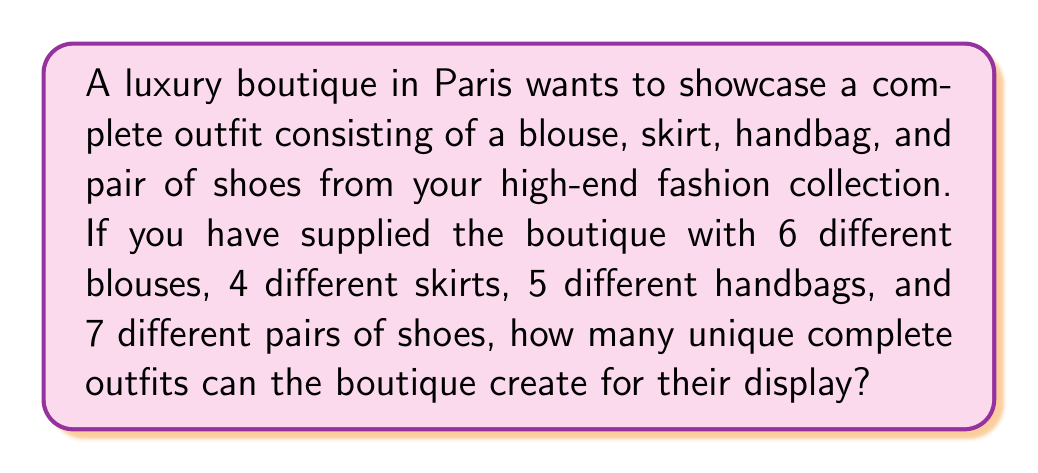Solve this math problem. To solve this problem, we'll use the multiplication principle of counting. Since we need to select one item from each category, and the selection of one item doesn't affect the choices for the other items, we multiply the number of options for each category:

1. Number of blouse options: 6
2. Number of skirt options: 4
3. Number of handbag options: 5
4. Number of shoe options: 7

The total number of unique outfits is the product of these numbers:

$$ \text{Total outfits} = 6 \times 4 \times 5 \times 7 $$

Let's calculate:

$$ \begin{align}
\text{Total outfits} &= 6 \times 4 \times 5 \times 7 \\
&= 24 \times 5 \times 7 \\
&= 120 \times 7 \\
&= 840
\end{align} $$

Therefore, the boutique can create 840 unique complete outfits for their display.
Answer: 840 outfits 